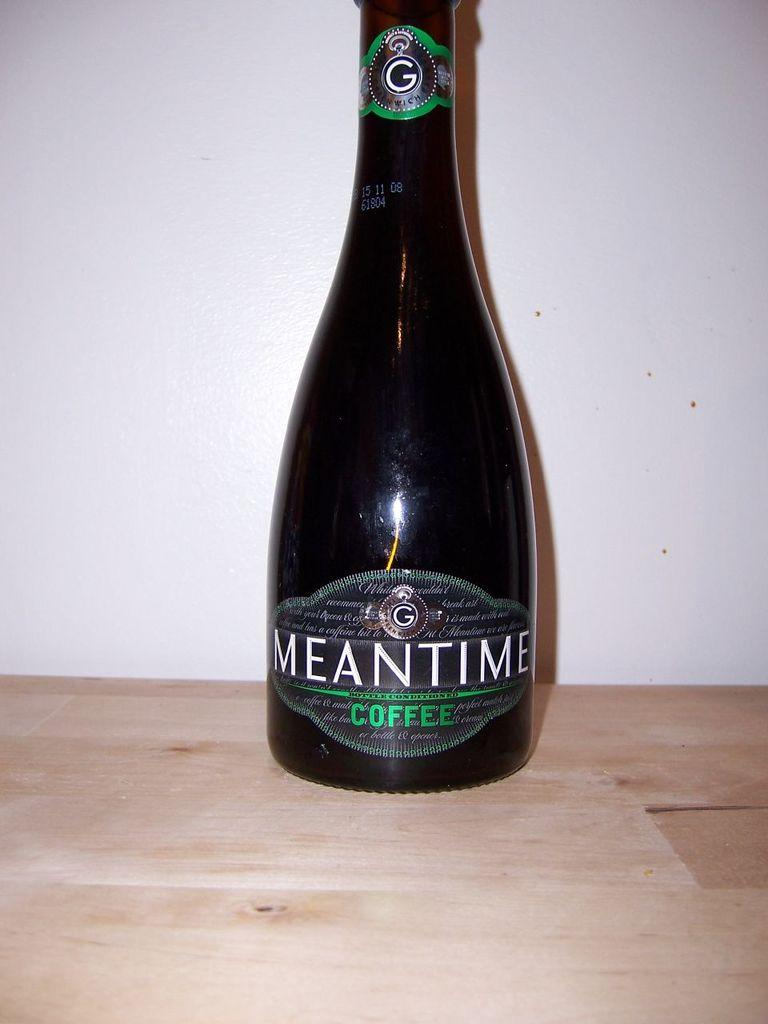<image>
Present a compact description of the photo's key features. A bottle of Meantime Coffee sits on a wooden table. 